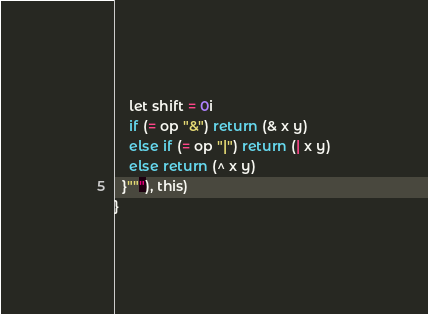<code> <loc_0><loc_0><loc_500><loc_500><_Scala_>    let shift = 0i
    if (= op "&") return (& x y)
    else if (= op "|") return (| x y)
    else return (^ x y)
  }"""), this)
}
</code> 